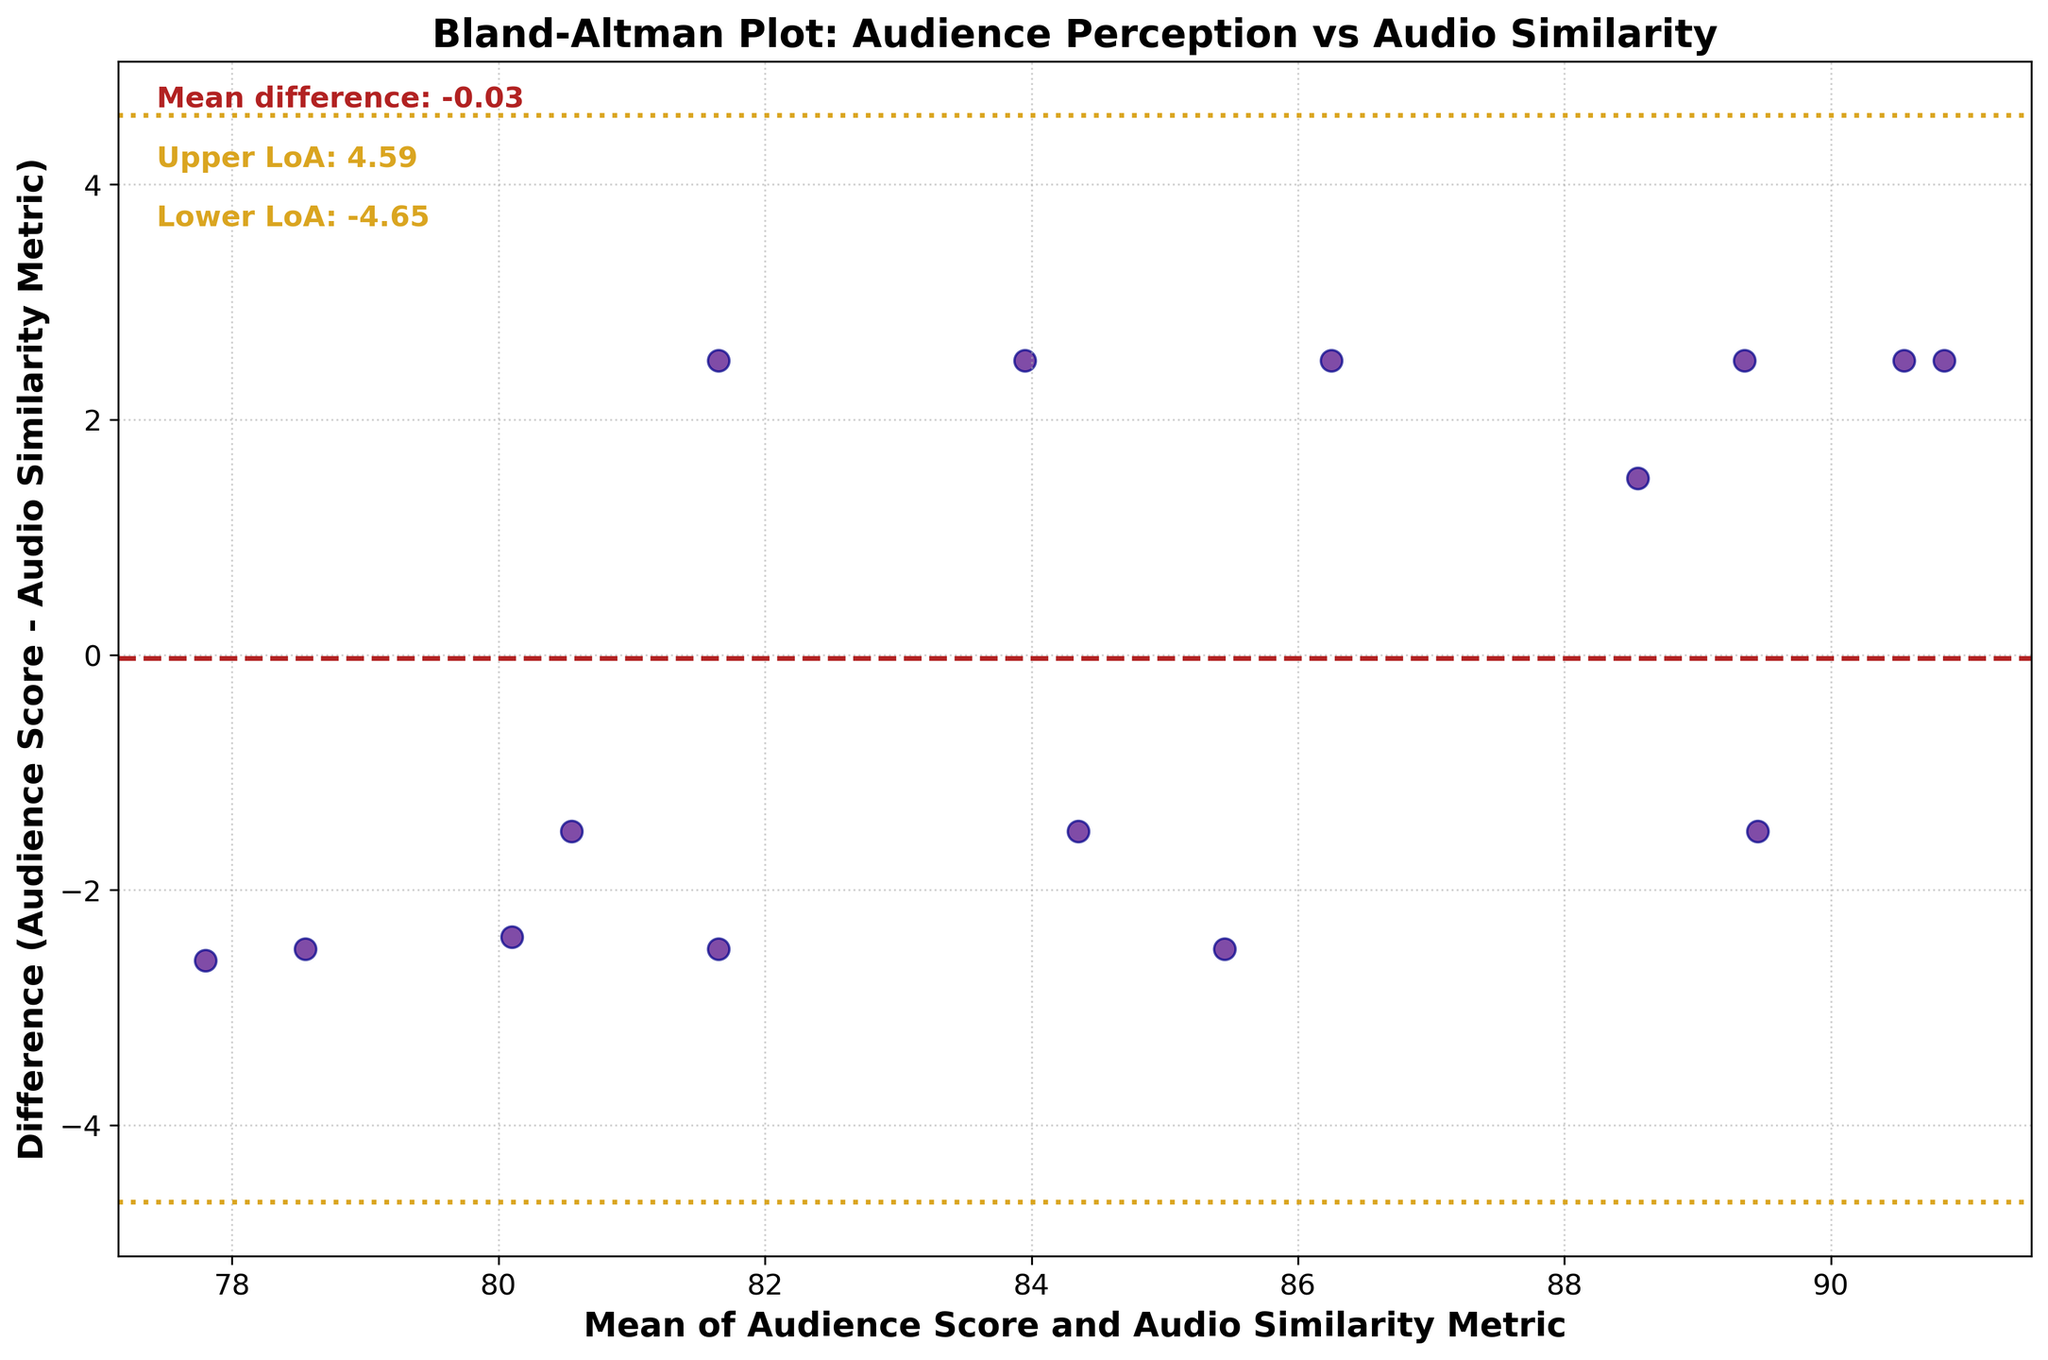How many data points are represented in the plot? The scatter plot shows individual points representing tribute concerts. Counting these points reveals there are 15 data points.
Answer: 15 What are the labels on the x-axis and y-axis? The x-axis is labeled 'Mean of Audience Score and Audio Similarity Metric', and the y-axis is labeled 'Difference (Audience Score - Audio Similarity Metric)'.
Answer: Mean of Audience Score and Audio Similarity Metric, Difference (Audience Score - Audio Similarity Metric) What is the mean difference between Audience Score and Audio Similarity Metric? The plot displays a text annotation indicating the mean difference as a numerical value on the left top side. It states, 'Mean difference: 0.10'.
Answer: 0.10 What do the dotted and dashed lines on the plot represent? The dashed line represents the mean difference between Audience Score and Audio Similarity Metric. The dotted lines represent the limits of agreement (mean difference ± 1.96 times the standard deviation of the differences).
Answer: Mean difference, Limits of agreement Which concert has the highest mean score between Audience Score and Audio Similarity Metric? By locating the highest x-value on the graph and cross-referencing with the data, ‘One Night of Queen’ has the highest mean score.
Answer: One Night of Queen Which concert shows the greatest negative difference between Audience Score and Audio Similarity Metric? Identify the lowest point on the y-axis. 'Who's Next' exhibits the most negative difference between the Audience Score and the Audio Similarity Metric.
Answer: Who's Next What is the value of the upper limit of agreement (Upper LoA)? The text annotation on the plot indicates the upper limit of agreement as 2.59.
Answer: 2.59 Calculate the range of the limits of agreement. The range is the difference between the upper and lower limits of agreement. From the annotation: 2.59 (Upper LoA) - (-2.39) (Lower LoA) = 4.98.
Answer: 4.98 Is there a general pattern in whether Audience Scores tend to be higher or lower than Audio Similarity Metrics, based on the plot? There are more points below the zero line indicating that Audience Scores generally tend to be lower than the Audio Similarity Metrics.
Answer: Lower 